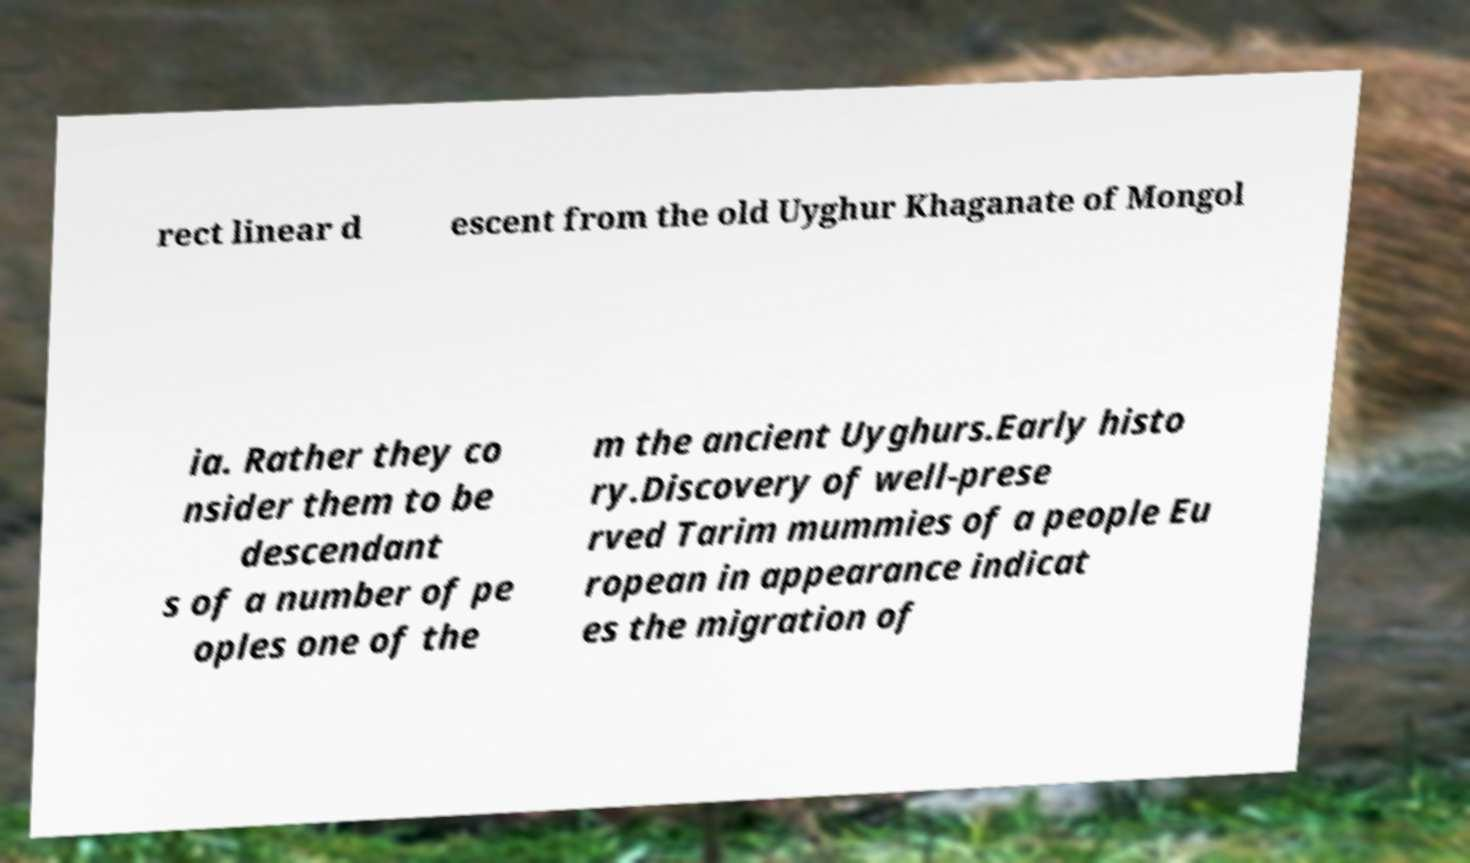Can you accurately transcribe the text from the provided image for me? rect linear d escent from the old Uyghur Khaganate of Mongol ia. Rather they co nsider them to be descendant s of a number of pe oples one of the m the ancient Uyghurs.Early histo ry.Discovery of well-prese rved Tarim mummies of a people Eu ropean in appearance indicat es the migration of 